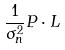<formula> <loc_0><loc_0><loc_500><loc_500>\frac { 1 } { \sigma _ { n } ^ { 2 } } P \cdot L</formula> 